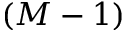<formula> <loc_0><loc_0><loc_500><loc_500>( M - 1 )</formula> 